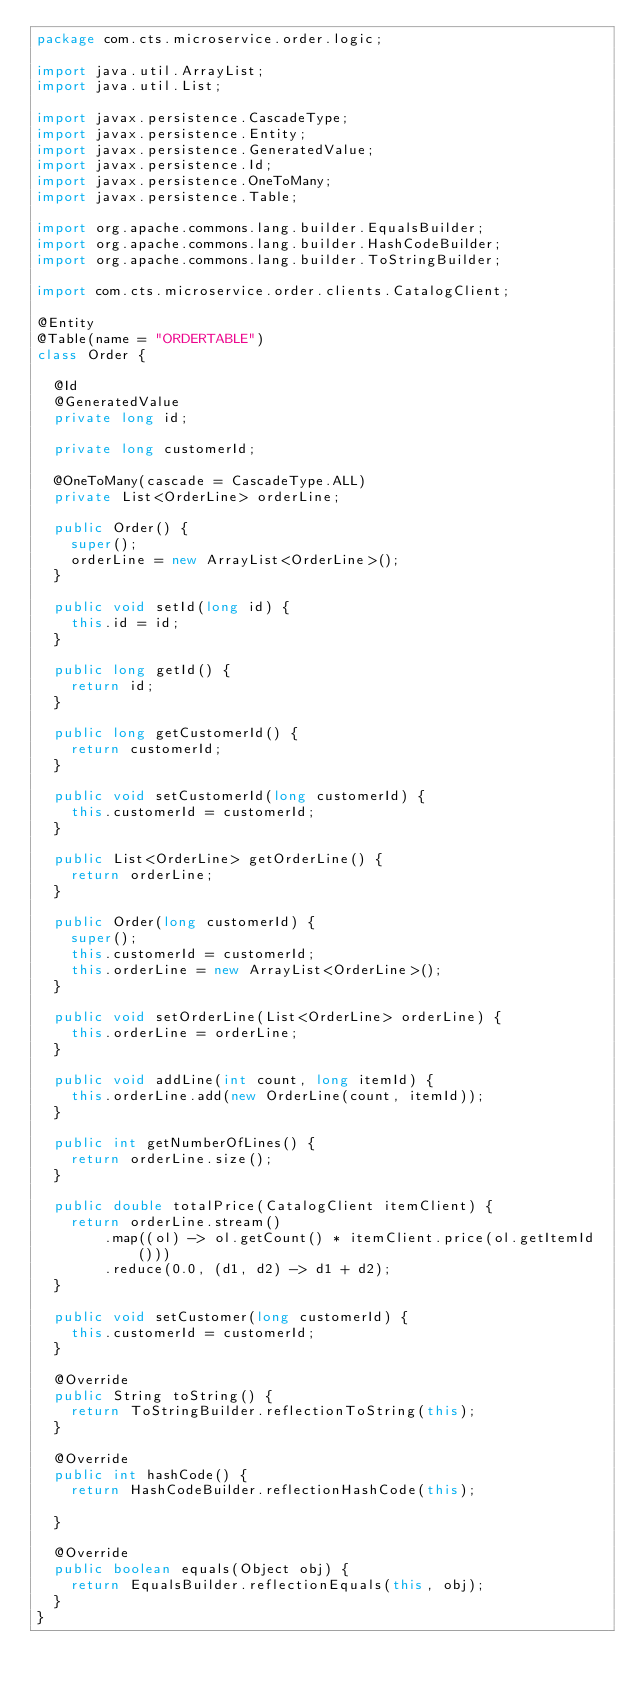<code> <loc_0><loc_0><loc_500><loc_500><_Java_>package com.cts.microservice.order.logic;

import java.util.ArrayList;
import java.util.List;

import javax.persistence.CascadeType;
import javax.persistence.Entity;
import javax.persistence.GeneratedValue;
import javax.persistence.Id;
import javax.persistence.OneToMany;
import javax.persistence.Table;

import org.apache.commons.lang.builder.EqualsBuilder;
import org.apache.commons.lang.builder.HashCodeBuilder;
import org.apache.commons.lang.builder.ToStringBuilder;

import com.cts.microservice.order.clients.CatalogClient;

@Entity
@Table(name = "ORDERTABLE")
class Order {

	@Id
	@GeneratedValue
	private long id;

	private long customerId;

	@OneToMany(cascade = CascadeType.ALL)
	private List<OrderLine> orderLine;

	public Order() {
		super();
		orderLine = new ArrayList<OrderLine>();
	}

	public void setId(long id) {
		this.id = id;
	}

	public long getId() {
		return id;
	}

	public long getCustomerId() {
		return customerId;
	}

	public void setCustomerId(long customerId) {
		this.customerId = customerId;
	}

	public List<OrderLine> getOrderLine() {
		return orderLine;
	}

	public Order(long customerId) {
		super();
		this.customerId = customerId;
		this.orderLine = new ArrayList<OrderLine>();
	}

	public void setOrderLine(List<OrderLine> orderLine) {
		this.orderLine = orderLine;
	}

	public void addLine(int count, long itemId) {
		this.orderLine.add(new OrderLine(count, itemId));
	}

	public int getNumberOfLines() {
		return orderLine.size();
	}

	public double totalPrice(CatalogClient itemClient) {
		return orderLine.stream()
				.map((ol) -> ol.getCount() * itemClient.price(ol.getItemId()))
				.reduce(0.0, (d1, d2) -> d1 + d2);
	}

	public void setCustomer(long customerId) {
		this.customerId = customerId;
	}

	@Override
	public String toString() {
		return ToStringBuilder.reflectionToString(this);
	}

	@Override
	public int hashCode() {
		return HashCodeBuilder.reflectionHashCode(this);

	}

	@Override
	public boolean equals(Object obj) {
		return EqualsBuilder.reflectionEquals(this, obj);
	}
}
</code> 